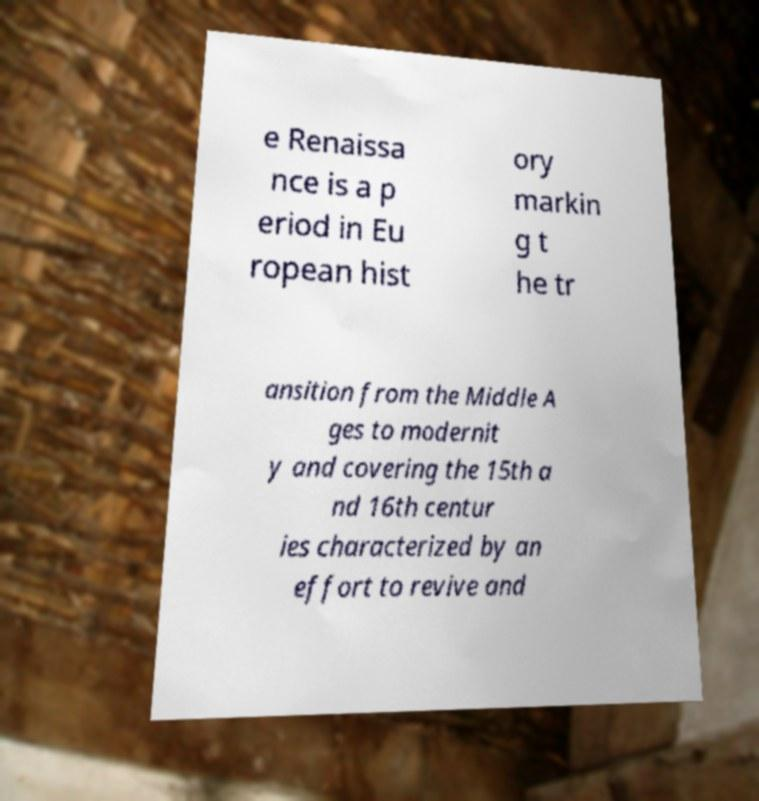Please identify and transcribe the text found in this image. e Renaissa nce is a p eriod in Eu ropean hist ory markin g t he tr ansition from the Middle A ges to modernit y and covering the 15th a nd 16th centur ies characterized by an effort to revive and 